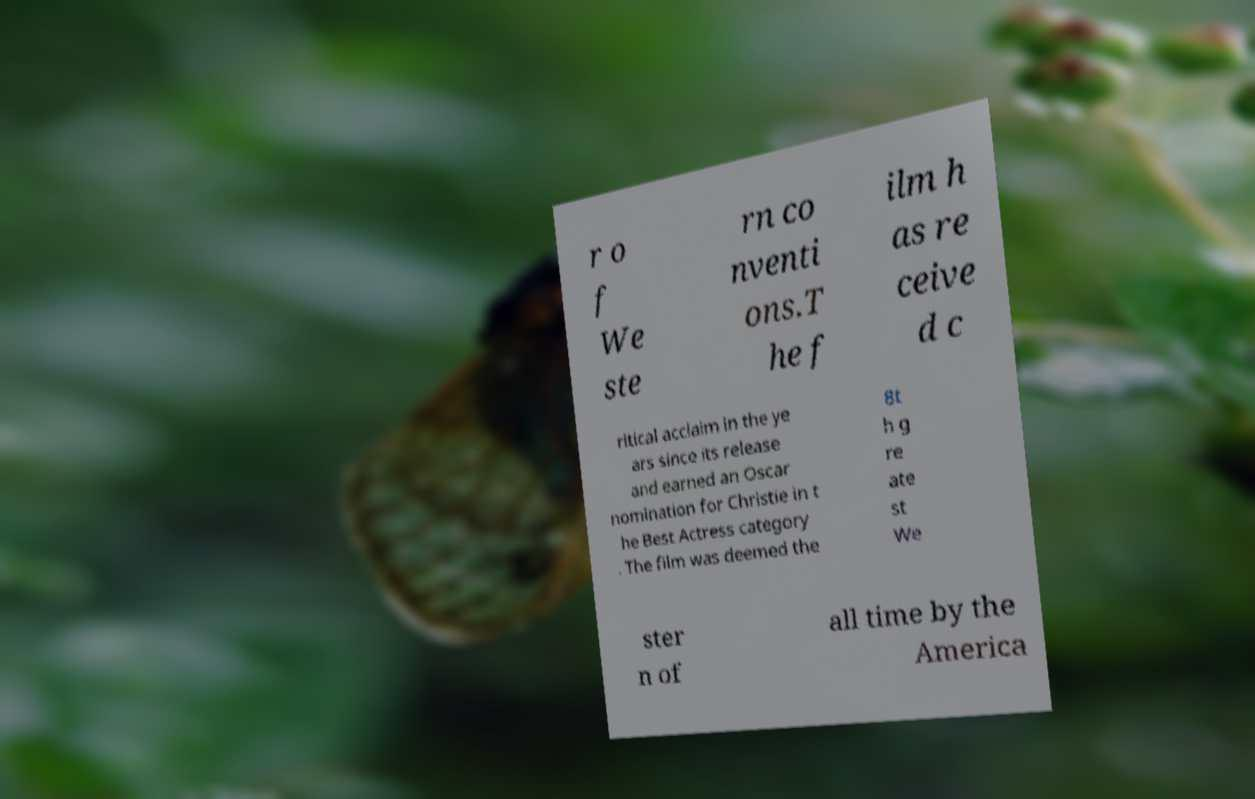Could you assist in decoding the text presented in this image and type it out clearly? r o f We ste rn co nventi ons.T he f ilm h as re ceive d c ritical acclaim in the ye ars since its release and earned an Oscar nomination for Christie in t he Best Actress category . The film was deemed the 8t h g re ate st We ster n of all time by the America 